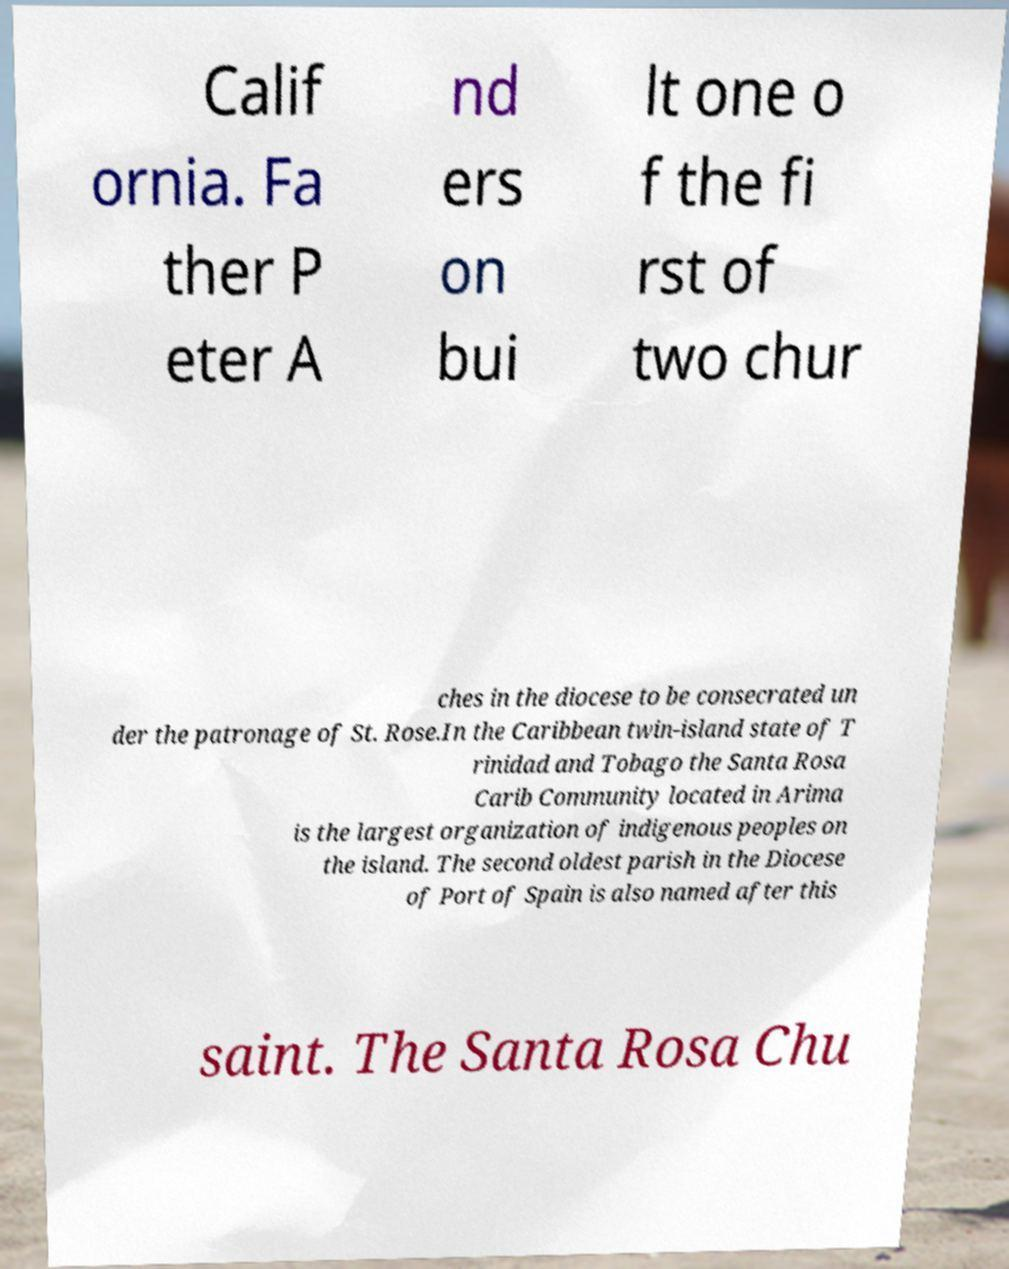Please identify and transcribe the text found in this image. Calif ornia. Fa ther P eter A nd ers on bui lt one o f the fi rst of two chur ches in the diocese to be consecrated un der the patronage of St. Rose.In the Caribbean twin-island state of T rinidad and Tobago the Santa Rosa Carib Community located in Arima is the largest organization of indigenous peoples on the island. The second oldest parish in the Diocese of Port of Spain is also named after this saint. The Santa Rosa Chu 